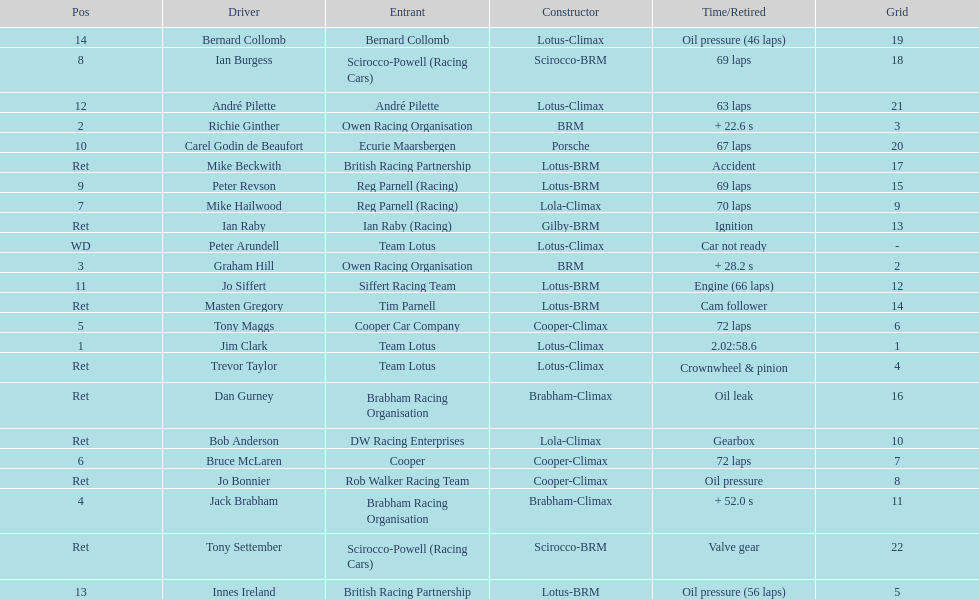Could you parse the entire table as a dict? {'header': ['Pos', 'Driver', 'Entrant', 'Constructor', 'Time/Retired', 'Grid'], 'rows': [['14', 'Bernard Collomb', 'Bernard Collomb', 'Lotus-Climax', 'Oil pressure (46 laps)', '19'], ['8', 'Ian Burgess', 'Scirocco-Powell (Racing Cars)', 'Scirocco-BRM', '69 laps', '18'], ['12', 'André Pilette', 'André Pilette', 'Lotus-Climax', '63 laps', '21'], ['2', 'Richie Ginther', 'Owen Racing Organisation', 'BRM', '+ 22.6 s', '3'], ['10', 'Carel Godin de Beaufort', 'Ecurie Maarsbergen', 'Porsche', '67 laps', '20'], ['Ret', 'Mike Beckwith', 'British Racing Partnership', 'Lotus-BRM', 'Accident', '17'], ['9', 'Peter Revson', 'Reg Parnell (Racing)', 'Lotus-BRM', '69 laps', '15'], ['7', 'Mike Hailwood', 'Reg Parnell (Racing)', 'Lola-Climax', '70 laps', '9'], ['Ret', 'Ian Raby', 'Ian Raby (Racing)', 'Gilby-BRM', 'Ignition', '13'], ['WD', 'Peter Arundell', 'Team Lotus', 'Lotus-Climax', 'Car not ready', '-'], ['3', 'Graham Hill', 'Owen Racing Organisation', 'BRM', '+ 28.2 s', '2'], ['11', 'Jo Siffert', 'Siffert Racing Team', 'Lotus-BRM', 'Engine (66 laps)', '12'], ['Ret', 'Masten Gregory', 'Tim Parnell', 'Lotus-BRM', 'Cam follower', '14'], ['5', 'Tony Maggs', 'Cooper Car Company', 'Cooper-Climax', '72 laps', '6'], ['1', 'Jim Clark', 'Team Lotus', 'Lotus-Climax', '2.02:58.6', '1'], ['Ret', 'Trevor Taylor', 'Team Lotus', 'Lotus-Climax', 'Crownwheel & pinion', '4'], ['Ret', 'Dan Gurney', 'Brabham Racing Organisation', 'Brabham-Climax', 'Oil leak', '16'], ['Ret', 'Bob Anderson', 'DW Racing Enterprises', 'Lola-Climax', 'Gearbox', '10'], ['6', 'Bruce McLaren', 'Cooper', 'Cooper-Climax', '72 laps', '7'], ['Ret', 'Jo Bonnier', 'Rob Walker Racing Team', 'Cooper-Climax', 'Oil pressure', '8'], ['4', 'Jack Brabham', 'Brabham Racing Organisation', 'Brabham-Climax', '+ 52.0 s', '11'], ['Ret', 'Tony Settember', 'Scirocco-Powell (Racing Cars)', 'Scirocco-BRM', 'Valve gear', '22'], ['13', 'Innes Ireland', 'British Racing Partnership', 'Lotus-BRM', 'Oil pressure (56 laps)', '5']]} Who came in first? Jim Clark. 